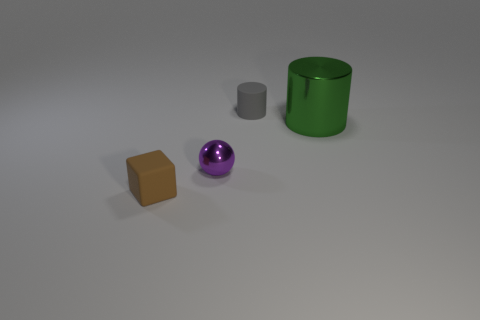There is a rubber object to the left of the cylinder behind the green shiny thing; what is its size?
Offer a very short reply. Small. There is a tiny matte cylinder; does it have the same color as the metallic object that is in front of the green cylinder?
Your answer should be very brief. No. There is a cylinder that is the same size as the purple shiny ball; what is its material?
Your answer should be very brief. Rubber. Is the number of purple shiny objects behind the tiny gray object less than the number of small metal things that are in front of the purple metallic thing?
Keep it short and to the point. No. What shape is the metallic object on the left side of the matte object that is to the right of the tiny brown thing?
Your response must be concise. Sphere. Are any small things visible?
Give a very brief answer. Yes. The tiny rubber thing that is on the left side of the gray rubber cylinder is what color?
Offer a very short reply. Brown. There is a small purple sphere; are there any gray cylinders in front of it?
Your answer should be compact. No. Are there more large things than large cubes?
Make the answer very short. Yes. There is a tiny rubber object that is in front of the small matte thing on the right side of the small matte thing that is left of the matte cylinder; what is its color?
Your answer should be compact. Brown. 